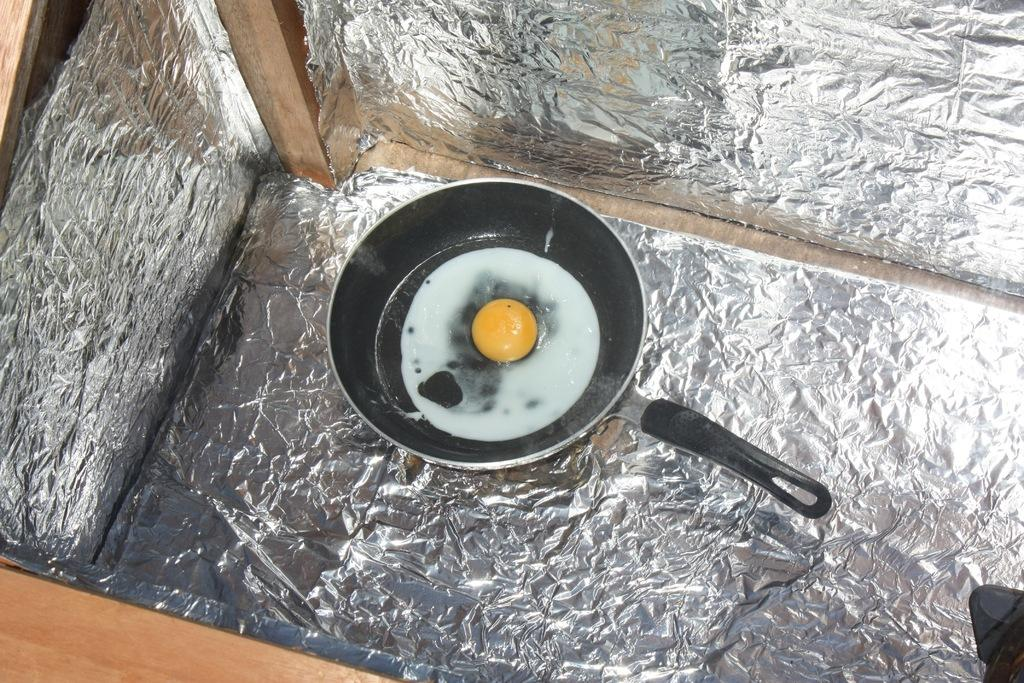What is being cooked in the frying pan in the image? There is egg white and yolk in a frying pan in the image. What other items can be seen in the image? There are silver foils in the image. What is the wooden object surrounded by the silver foils? The wooden object is surrounded by the silver foils in the image. What type of ball is rolling through the stream in the image? There is no ball or stream present in the image. 